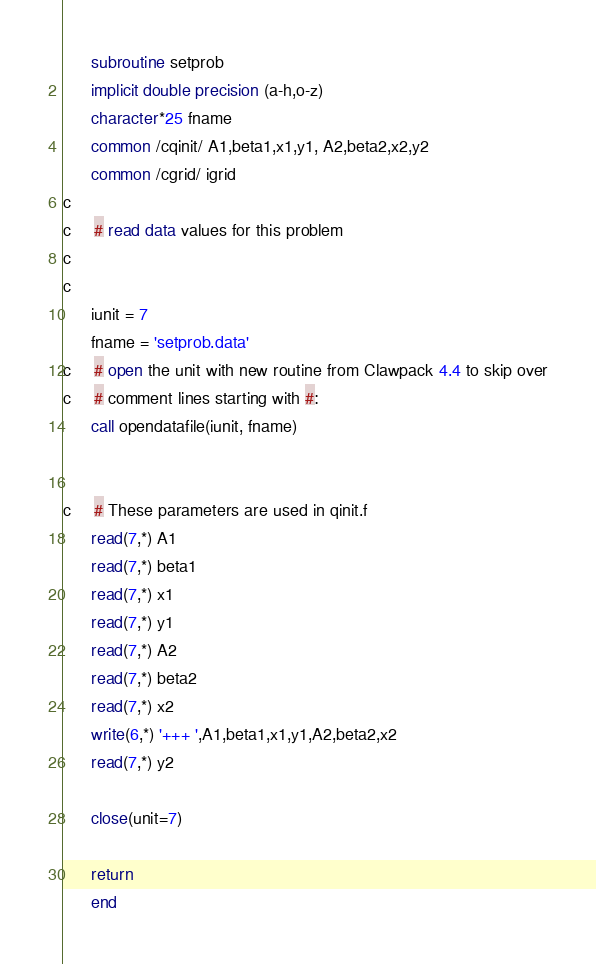<code> <loc_0><loc_0><loc_500><loc_500><_FORTRAN_>      subroutine setprob
      implicit double precision (a-h,o-z)
      character*25 fname
      common /cqinit/ A1,beta1,x1,y1, A2,beta2,x2,y2
      common /cgrid/ igrid
c
c     # read data values for this problem
c
c
      iunit = 7
      fname = 'setprob.data'
c     # open the unit with new routine from Clawpack 4.4 to skip over
c     # comment lines starting with #:
      call opendatafile(iunit, fname)
                

c     # These parameters are used in qinit.f
      read(7,*) A1
      read(7,*) beta1
      read(7,*) x1
      read(7,*) y1
      read(7,*) A2
      read(7,*) beta2
      read(7,*) x2
      write(6,*) '+++ ',A1,beta1,x1,y1,A2,beta2,x2
      read(7,*) y2

      close(unit=7)

      return
      end
</code> 